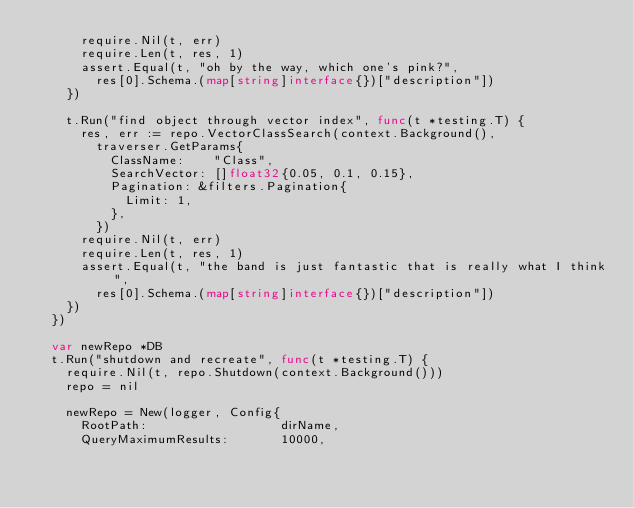<code> <loc_0><loc_0><loc_500><loc_500><_Go_>			require.Nil(t, err)
			require.Len(t, res, 1)
			assert.Equal(t, "oh by the way, which one's pink?",
				res[0].Schema.(map[string]interface{})["description"])
		})

		t.Run("find object through vector index", func(t *testing.T) {
			res, err := repo.VectorClassSearch(context.Background(),
				traverser.GetParams{
					ClassName:    "Class",
					SearchVector: []float32{0.05, 0.1, 0.15},
					Pagination: &filters.Pagination{
						Limit: 1,
					},
				})
			require.Nil(t, err)
			require.Len(t, res, 1)
			assert.Equal(t, "the band is just fantastic that is really what I think",
				res[0].Schema.(map[string]interface{})["description"])
		})
	})

	var newRepo *DB
	t.Run("shutdown and recreate", func(t *testing.T) {
		require.Nil(t, repo.Shutdown(context.Background()))
		repo = nil

		newRepo = New(logger, Config{
			RootPath:                  dirName,
			QueryMaximumResults:       10000,</code> 